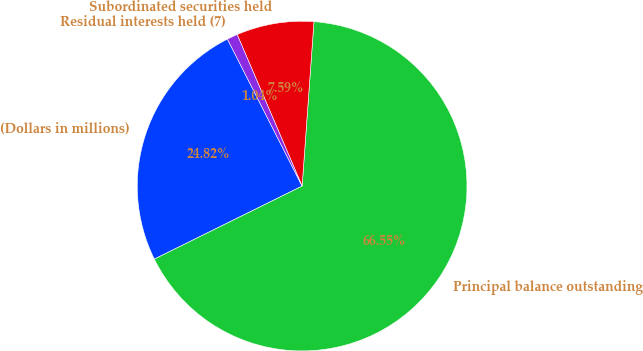Convert chart to OTSL. <chart><loc_0><loc_0><loc_500><loc_500><pie_chart><fcel>(Dollars in millions)<fcel>Principal balance outstanding<fcel>Subordinated securities held<fcel>Residual interests held (7)<nl><fcel>24.82%<fcel>66.55%<fcel>7.59%<fcel>1.04%<nl></chart> 